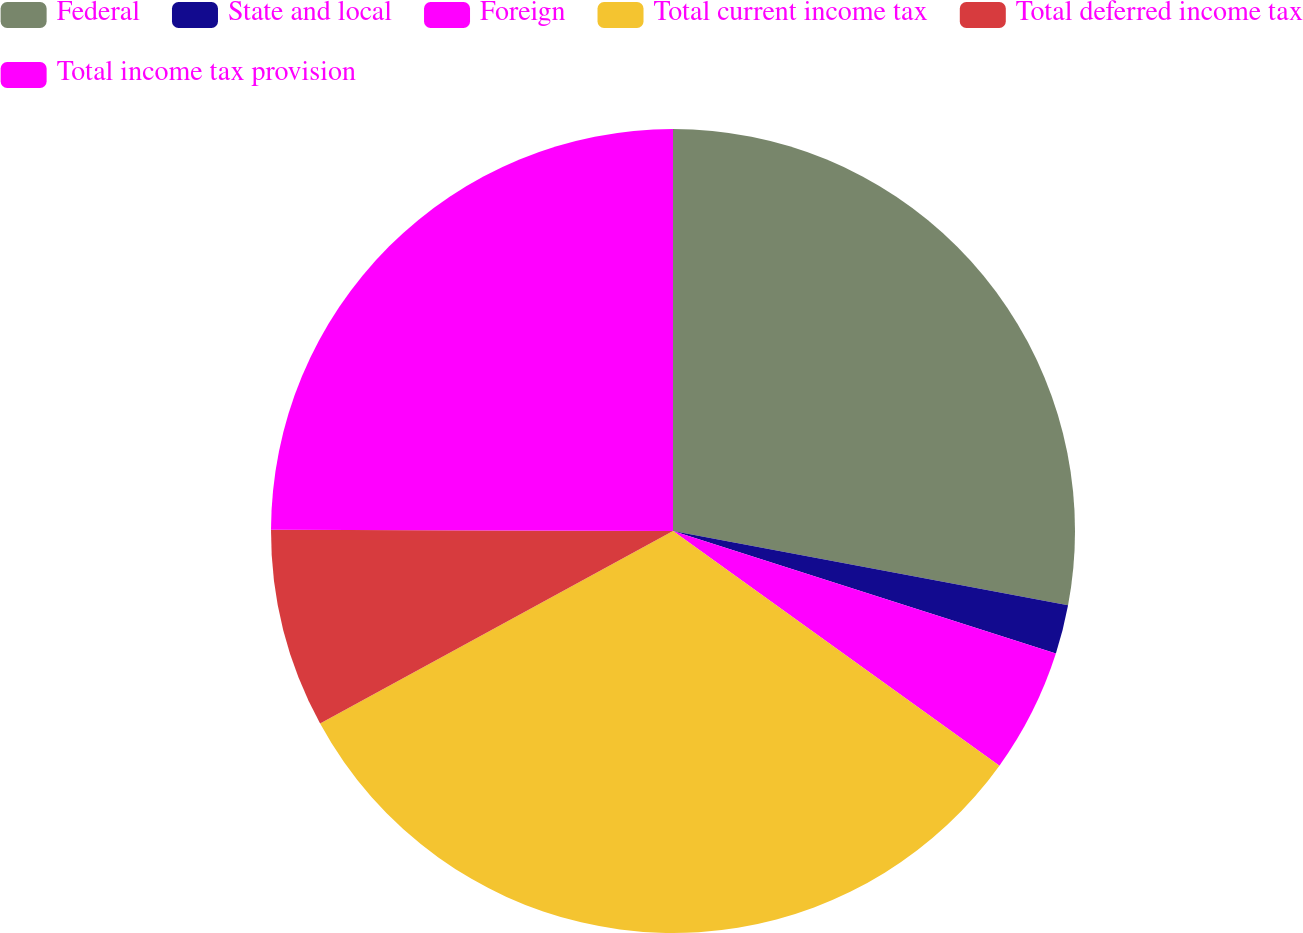<chart> <loc_0><loc_0><loc_500><loc_500><pie_chart><fcel>Federal<fcel>State and local<fcel>Foreign<fcel>Total current income tax<fcel>Total deferred income tax<fcel>Total income tax provision<nl><fcel>27.96%<fcel>1.97%<fcel>4.99%<fcel>32.13%<fcel>8.0%<fcel>24.95%<nl></chart> 